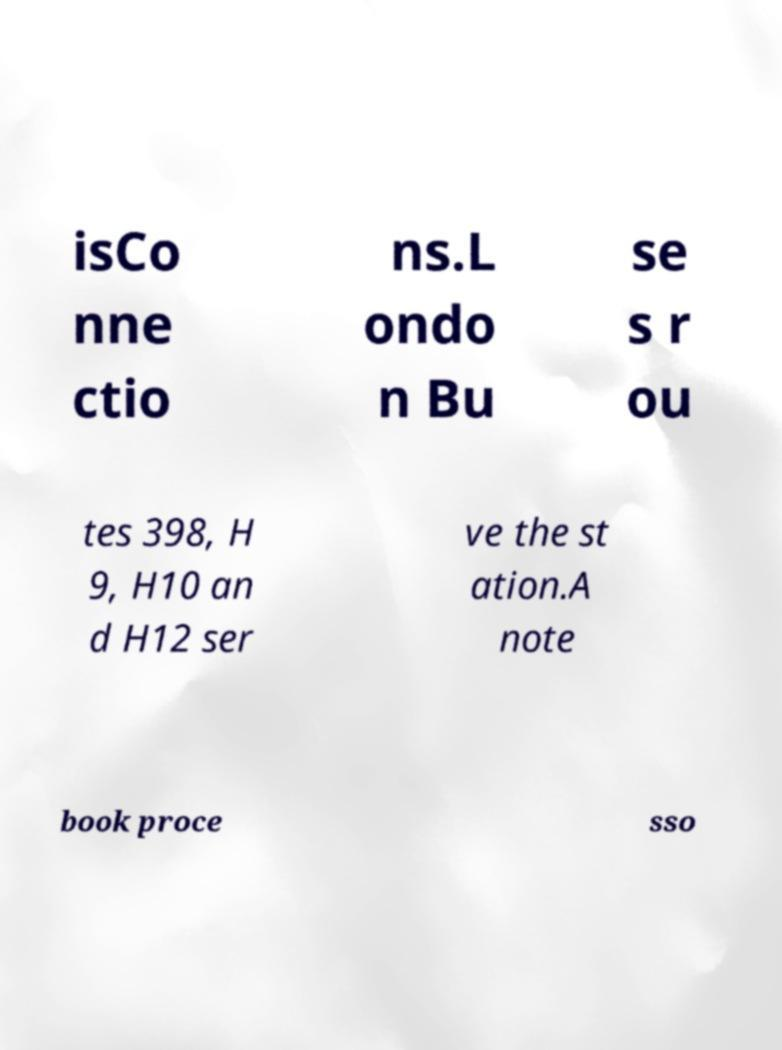For documentation purposes, I need the text within this image transcribed. Could you provide that? isCo nne ctio ns.L ondo n Bu se s r ou tes 398, H 9, H10 an d H12 ser ve the st ation.A note book proce sso 